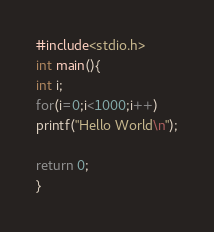Convert code to text. <code><loc_0><loc_0><loc_500><loc_500><_C_>#include<stdio.h>
int main(){
int i;
for(i=0;i<1000;i++)
printf("Hello World\n");

return 0;
}</code> 